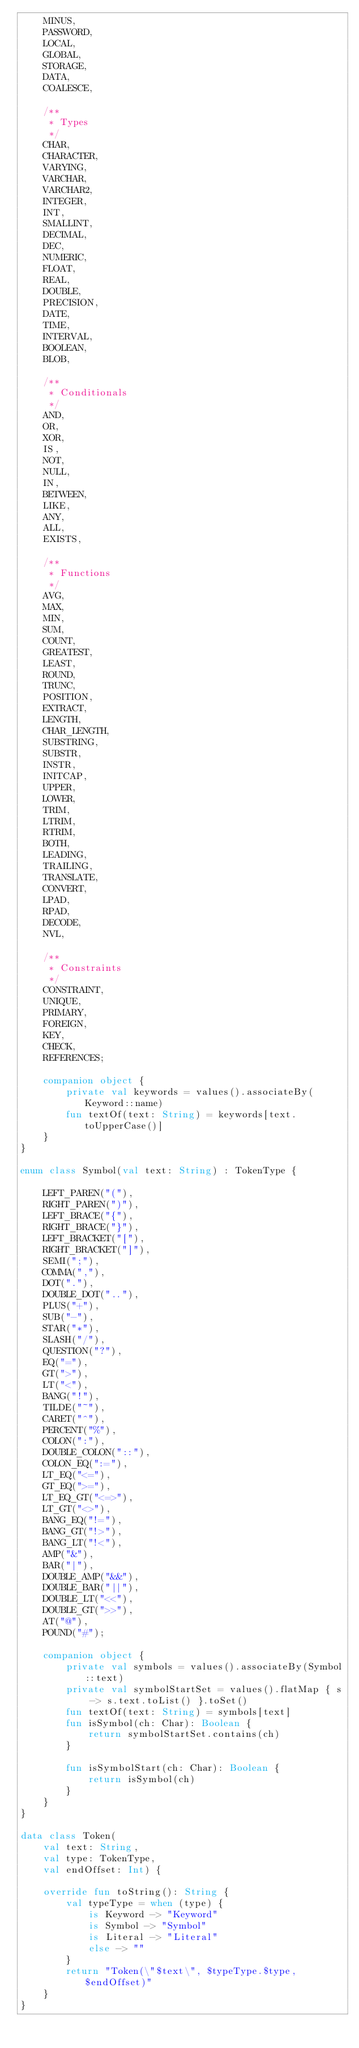<code> <loc_0><loc_0><loc_500><loc_500><_Kotlin_>    MINUS,
    PASSWORD,
    LOCAL,
    GLOBAL,
    STORAGE,
    DATA,
    COALESCE,

    /**
     * Types
     */
    CHAR,
    CHARACTER,
    VARYING,
    VARCHAR,
    VARCHAR2,
    INTEGER,
    INT,
    SMALLINT,
    DECIMAL,
    DEC,
    NUMERIC,
    FLOAT,
    REAL,
    DOUBLE,
    PRECISION,
    DATE,
    TIME,
    INTERVAL,
    BOOLEAN,
    BLOB,

    /**
     * Conditionals
     */
    AND,
    OR,
    XOR,
    IS,
    NOT,
    NULL,
    IN,
    BETWEEN,
    LIKE,
    ANY,
    ALL,
    EXISTS,

    /**
     * Functions
     */
    AVG,
    MAX,
    MIN,
    SUM,
    COUNT,
    GREATEST,
    LEAST,
    ROUND,
    TRUNC,
    POSITION,
    EXTRACT,
    LENGTH,
    CHAR_LENGTH,
    SUBSTRING,
    SUBSTR,
    INSTR,
    INITCAP,
    UPPER,
    LOWER,
    TRIM,
    LTRIM,
    RTRIM,
    BOTH,
    LEADING,
    TRAILING,
    TRANSLATE,
    CONVERT,
    LPAD,
    RPAD,
    DECODE,
    NVL,

    /**
     * Constraints
     */
    CONSTRAINT,
    UNIQUE,
    PRIMARY,
    FOREIGN,
    KEY,
    CHECK,
    REFERENCES;

    companion object {
        private val keywords = values().associateBy(Keyword::name)
        fun textOf(text: String) = keywords[text.toUpperCase()]
    }
}

enum class Symbol(val text: String) : TokenType {

    LEFT_PAREN("("),
    RIGHT_PAREN(")"),
    LEFT_BRACE("{"),
    RIGHT_BRACE("}"),
    LEFT_BRACKET("["),
    RIGHT_BRACKET("]"),
    SEMI(";"),
    COMMA(","),
    DOT("."),
    DOUBLE_DOT(".."),
    PLUS("+"),
    SUB("-"),
    STAR("*"),
    SLASH("/"),
    QUESTION("?"),
    EQ("="),
    GT(">"),
    LT("<"),
    BANG("!"),
    TILDE("~"),
    CARET("^"),
    PERCENT("%"),
    COLON(":"),
    DOUBLE_COLON("::"),
    COLON_EQ(":="),
    LT_EQ("<="),
    GT_EQ(">="),
    LT_EQ_GT("<=>"),
    LT_GT("<>"),
    BANG_EQ("!="),
    BANG_GT("!>"),
    BANG_LT("!<"),
    AMP("&"),
    BAR("|"),
    DOUBLE_AMP("&&"),
    DOUBLE_BAR("||"),
    DOUBLE_LT("<<"),
    DOUBLE_GT(">>"),
    AT("@"),
    POUND("#");

    companion object {
        private val symbols = values().associateBy(Symbol::text)
        private val symbolStartSet = values().flatMap { s -> s.text.toList() }.toSet()
        fun textOf(text: String) = symbols[text]
        fun isSymbol(ch: Char): Boolean {
            return symbolStartSet.contains(ch)
        }

        fun isSymbolStart(ch: Char): Boolean {
            return isSymbol(ch)
        }
    }
}

data class Token(
    val text: String,
    val type: TokenType,
    val endOffset: Int) {

    override fun toString(): String {
        val typeType = when (type) {
            is Keyword -> "Keyword"
            is Symbol -> "Symbol"
            is Literal -> "Literal"
            else -> ""
        }
        return "Token(\"$text\", $typeType.$type, $endOffset)"
    }
}
</code> 